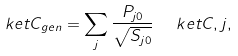Convert formula to latex. <formula><loc_0><loc_0><loc_500><loc_500>\ k e t { C _ { g e n } } = \sum _ { j } \frac { P _ { j 0 } } { \sqrt { S _ { j 0 } } } \ \ k e t { C , j } ,</formula> 